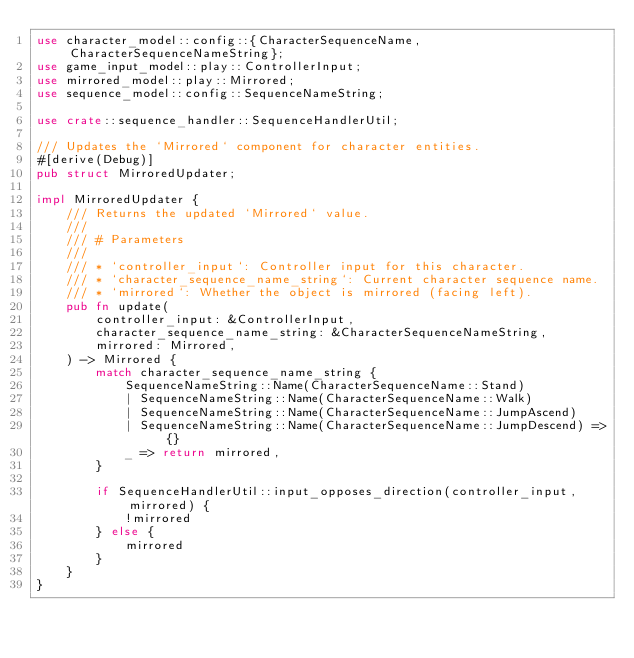Convert code to text. <code><loc_0><loc_0><loc_500><loc_500><_Rust_>use character_model::config::{CharacterSequenceName, CharacterSequenceNameString};
use game_input_model::play::ControllerInput;
use mirrored_model::play::Mirrored;
use sequence_model::config::SequenceNameString;

use crate::sequence_handler::SequenceHandlerUtil;

/// Updates the `Mirrored` component for character entities.
#[derive(Debug)]
pub struct MirroredUpdater;

impl MirroredUpdater {
    /// Returns the updated `Mirrored` value.
    ///
    /// # Parameters
    ///
    /// * `controller_input`: Controller input for this character.
    /// * `character_sequence_name_string`: Current character sequence name.
    /// * `mirrored`: Whether the object is mirrored (facing left).
    pub fn update(
        controller_input: &ControllerInput,
        character_sequence_name_string: &CharacterSequenceNameString,
        mirrored: Mirrored,
    ) -> Mirrored {
        match character_sequence_name_string {
            SequenceNameString::Name(CharacterSequenceName::Stand)
            | SequenceNameString::Name(CharacterSequenceName::Walk)
            | SequenceNameString::Name(CharacterSequenceName::JumpAscend)
            | SequenceNameString::Name(CharacterSequenceName::JumpDescend) => {}
            _ => return mirrored,
        }

        if SequenceHandlerUtil::input_opposes_direction(controller_input, mirrored) {
            !mirrored
        } else {
            mirrored
        }
    }
}
</code> 